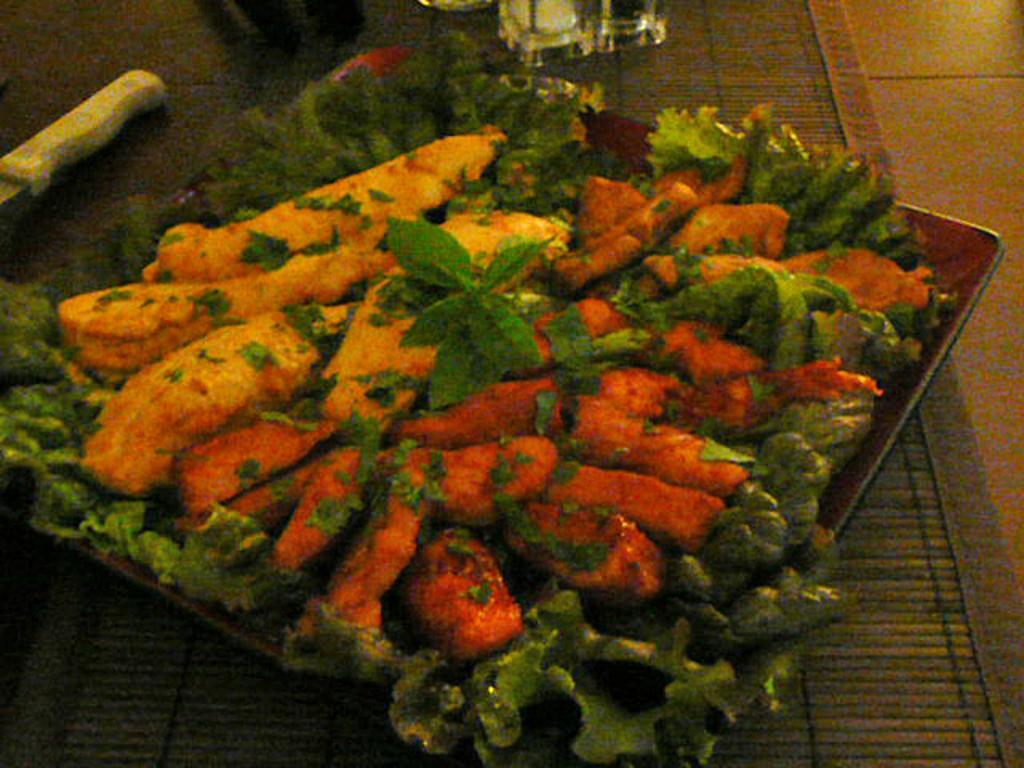In one or two sentences, can you explain what this image depicts? Here in this picture we can see some food item present on a plate and we can see mint leaves decorated around it and we can also see a knife present beside it and we can see spices bottles present. 